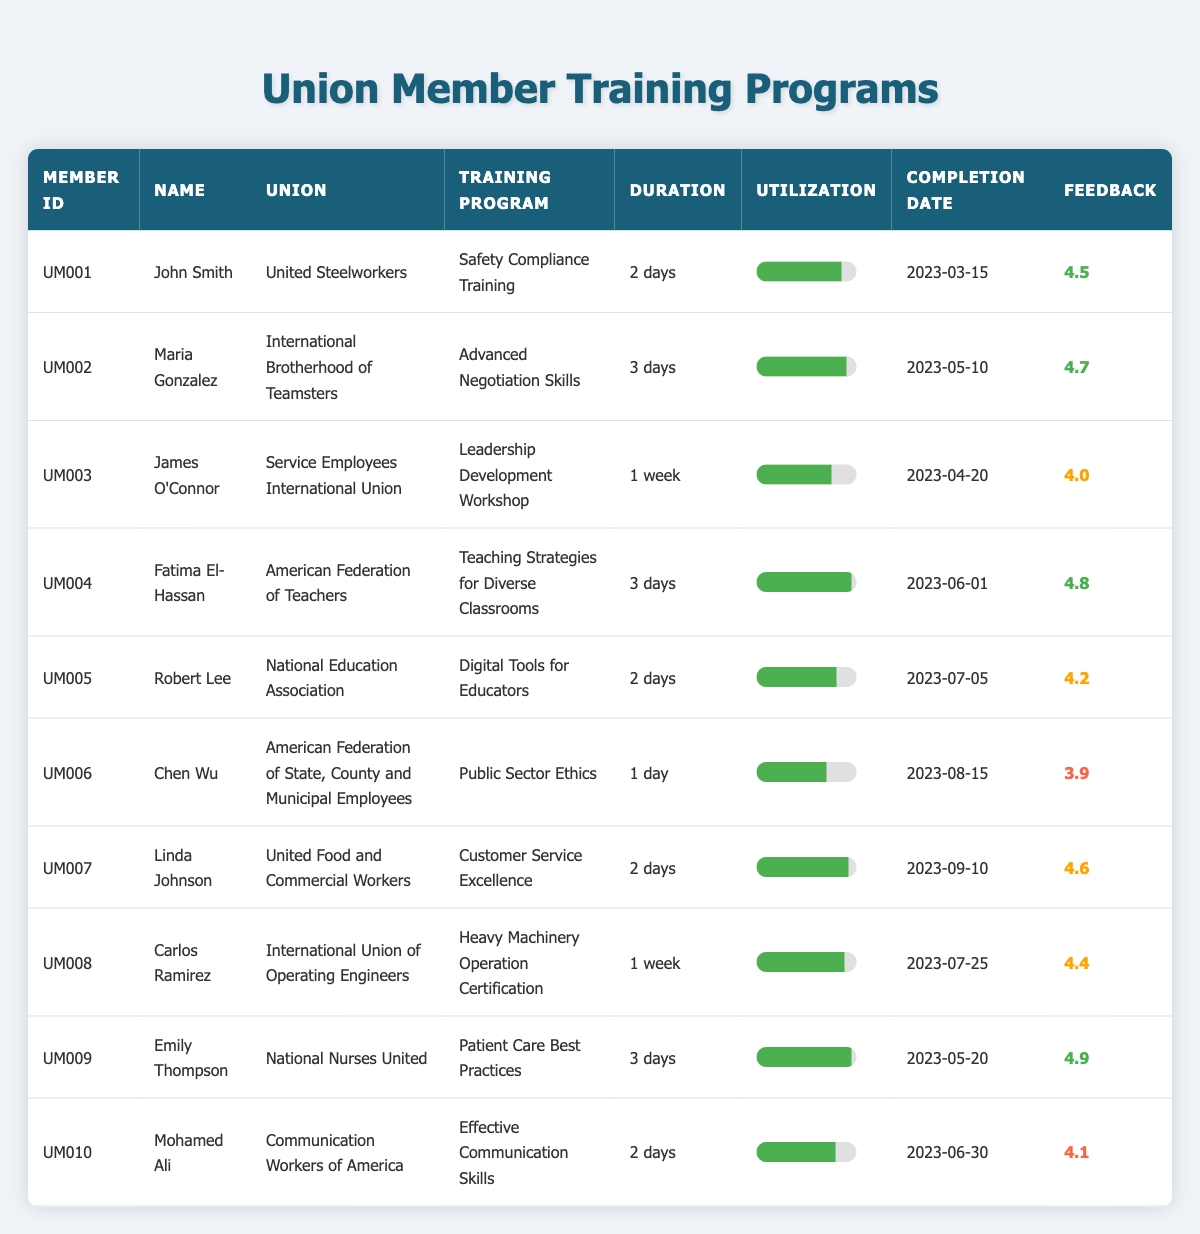What is the duration of the "Customer Service Excellence" training program? The table lists the training program "Customer Service Excellence" under Linda Johnson in the duration column, which shows "2 days".
Answer: 2 days Which union has the highest utilization percentage for training? By comparing the utilization percentages in the table, "Teaching Strategies for Diverse Classrooms" under Fatima El-Hassan has the highest utilization at 95%.
Answer: American Federation of Teachers How many training programs last for one week? The table lists two training programs with a duration of "1 week": "Leadership Development Workshop" by James O'Connor and "Heavy Machinery Operation Certification" by Carlos Ramirez, which makes a total of two.
Answer: 2 What percentage of members had a feedback rating of 4.5 or higher? There are 10 members, and 7 of them have feedback ratings of 4.5 or higher (John Smith, Maria Gonzalez, Fatima El-Hassan, Emily Thompson, Linda Johnson, Carlos Ramirez, and Robert Lee). To find the percentage, we calculate (7/10) * 100 = 70%.
Answer: 70% What is the average utilization percentage of all training programs? The utilization percentages are: 85, 90, 75, 95, 80, 70, 92, 88, 95, 79. Adding these values gives 85 + 90 + 75 + 95 + 80 + 70 + 92 + 88 + 95 + 79 = 919. The average is then 919/10 = 91.9%.
Answer: 91.9% Is it true that more than half of the members completed their training programs in March and April? Reviewing the completion dates, 3 members completed their training in March and April (John Smith, James O'Connor, and Maria Gonzalez) out of 10 total members, which is less than half. Therefore, the statement is false.
Answer: No What is the feedback rating range of the training programs? The highest feedback rating is 4.9 (Emily Thompson) and the lowest is 3.9 (Chen Wu). The range is calculated by subtracting the lowest rating from the highest: 4.9 - 3.9 = 1.0.
Answer: 1.0 How many programs have a program duration of "2 days"? By checking the duration column, the following training programs last for 2 days: "Safety Compliance Training", "Digital Tools for Educators", "Effective Communication Skills", and "Customer Service Excellence". This totals 4 programs.
Answer: 4 What is the total number of members from the "International Brotherhood of Teamsters" who completed their training? The only member listed from the "International Brotherhood of Teamsters" is Maria Gonzalez, who completed her training. Therefore, the total is one member.
Answer: 1 Which member received the highest feedback rating, and what is that rating? Emily Thompson has the highest feedback rating of 4.9 for her training in "Patient Care Best Practices".
Answer: Emily Thompson, 4.9 How many training programs received a feedback rating below 4.0? The table shows that only Chen Wu received a feedback rating of 3.9, which means there is 1 training program with a rating below 4.0.
Answer: 1 